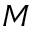<formula> <loc_0><loc_0><loc_500><loc_500>M</formula> 